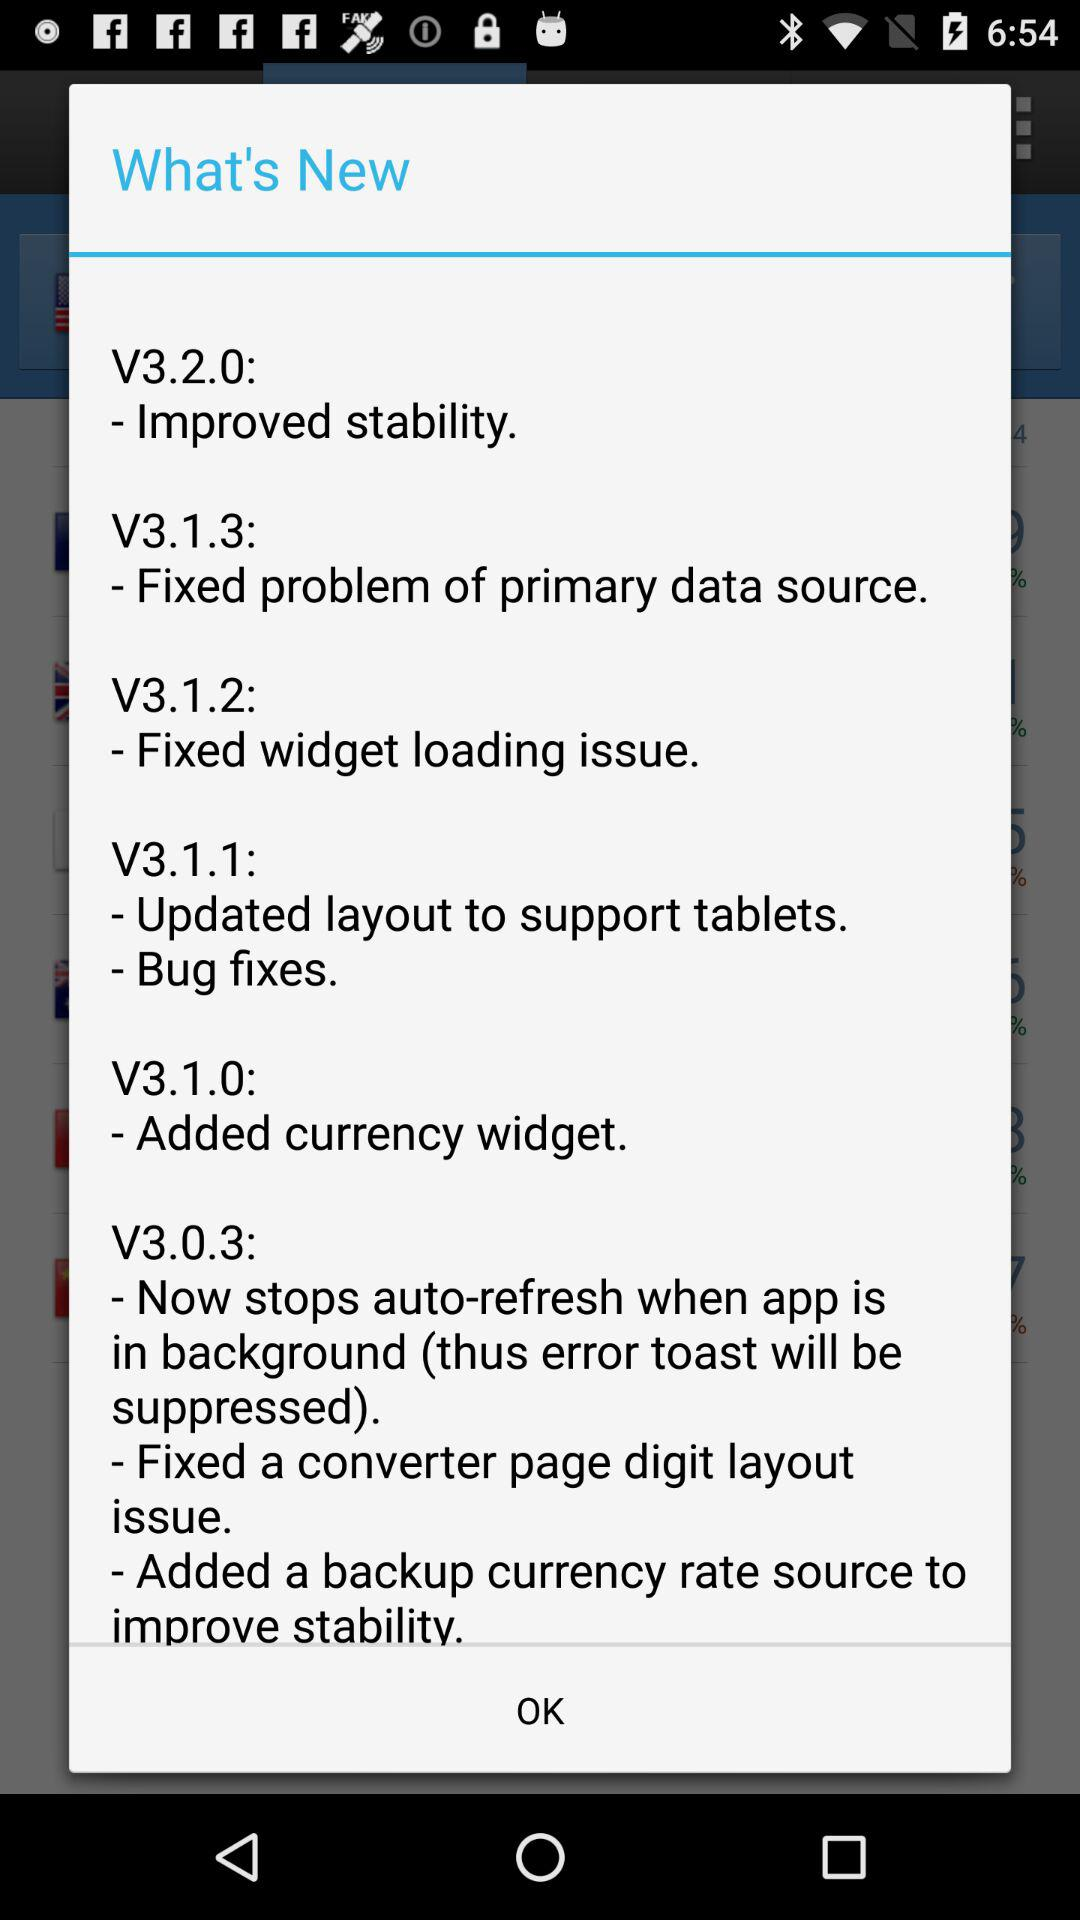What is the new feature in V3.1.3? The new feature is "Fixed problem of primary data source". 